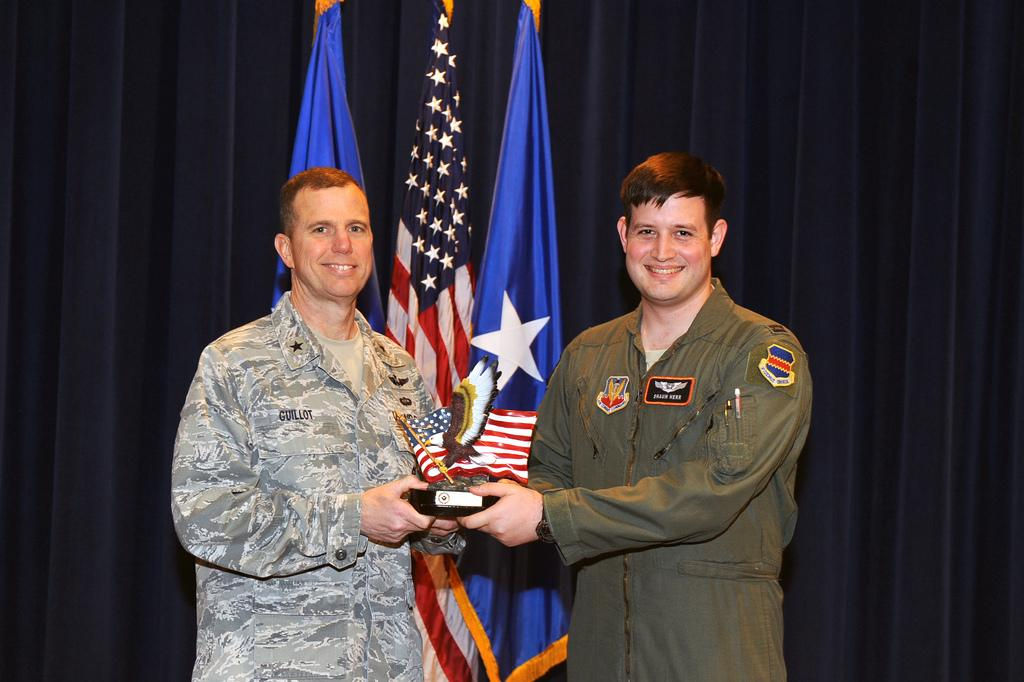How many people are in the image? There are two persons in the image. What are the two persons doing in the image? The two persons are standing and holding a box. What can be seen in the background of the image? There are flags, poles, and a curtain in the background of the image. What type of rhythm can be heard coming from the sidewalk in the image? There is no sidewalk present in the image, and therefore no rhythm can be heard. 